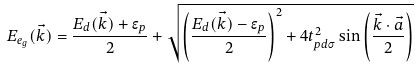<formula> <loc_0><loc_0><loc_500><loc_500>E _ { e _ { g } } ( \vec { k } ) = \frac { E _ { d } ( \vec { k } ) + \epsilon _ { p } } { 2 } + \sqrt { \left ( \frac { E _ { d } ( \vec { k } ) - \epsilon _ { p } } { 2 } \right ) ^ { 2 } + 4 t _ { p d \sigma } ^ { 2 } \sin \left ( \frac { \vec { k } \cdot \vec { a } } { 2 } \right ) }</formula> 